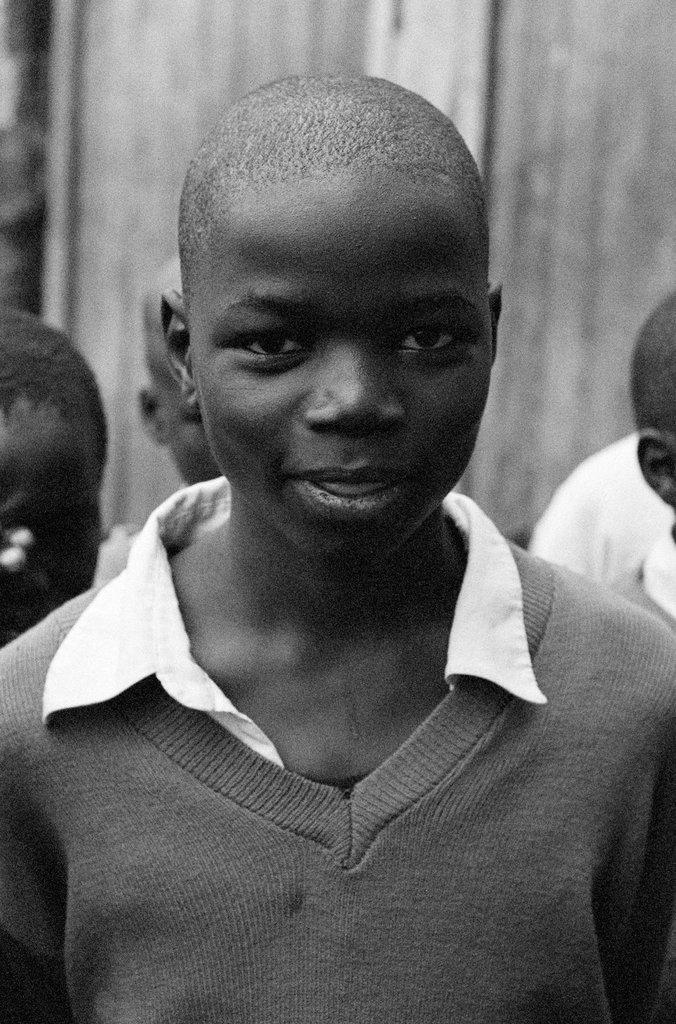What is the main subject of the image? There is a person in the image. Are there any other people visible in the image? Yes, there are other people behind the person. What is the color scheme of the image? The image is in black and white. What can be seen in the background of the image? There is a wall in the background of the image. What type of tooth is the person using to create the art in the image? There is no tooth or art present in the image. 